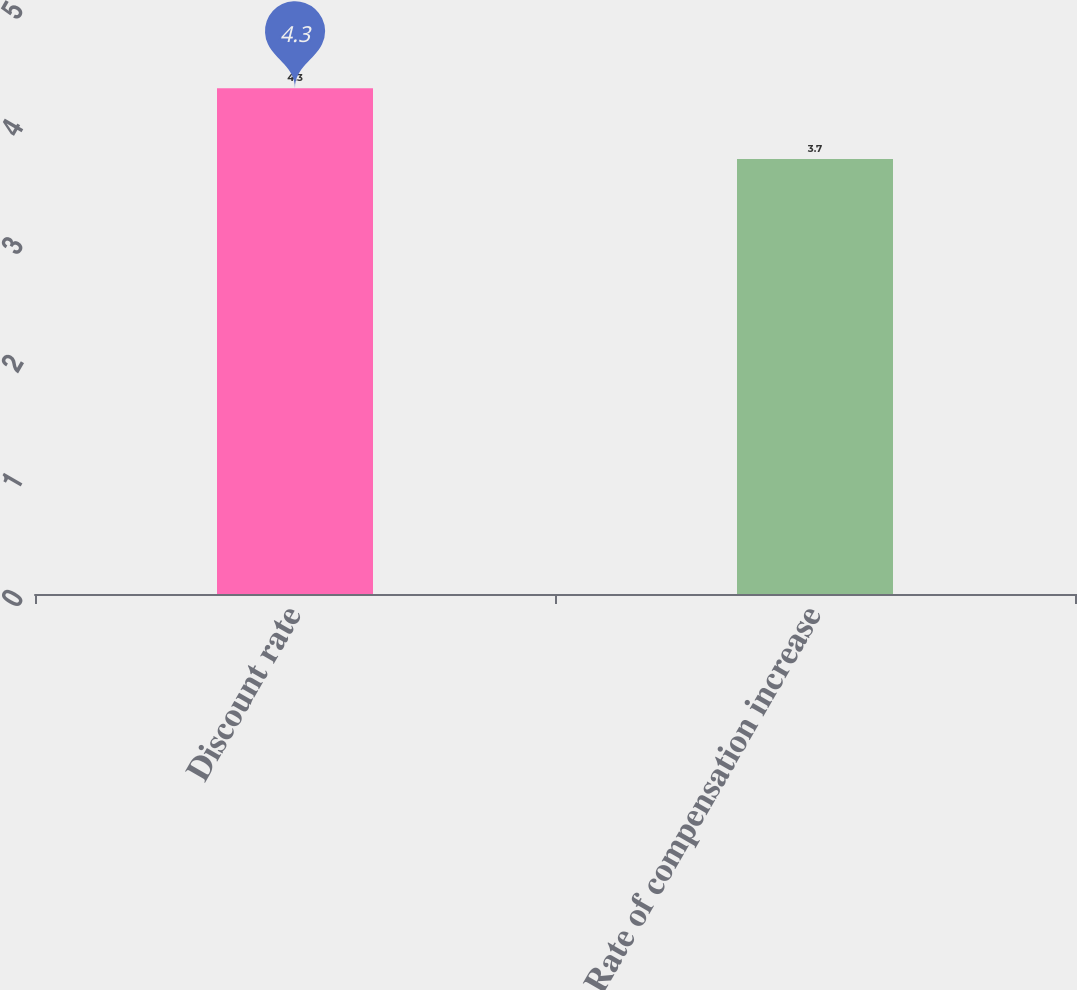<chart> <loc_0><loc_0><loc_500><loc_500><bar_chart><fcel>Discount rate<fcel>Rate of compensation increase<nl><fcel>4.3<fcel>3.7<nl></chart> 